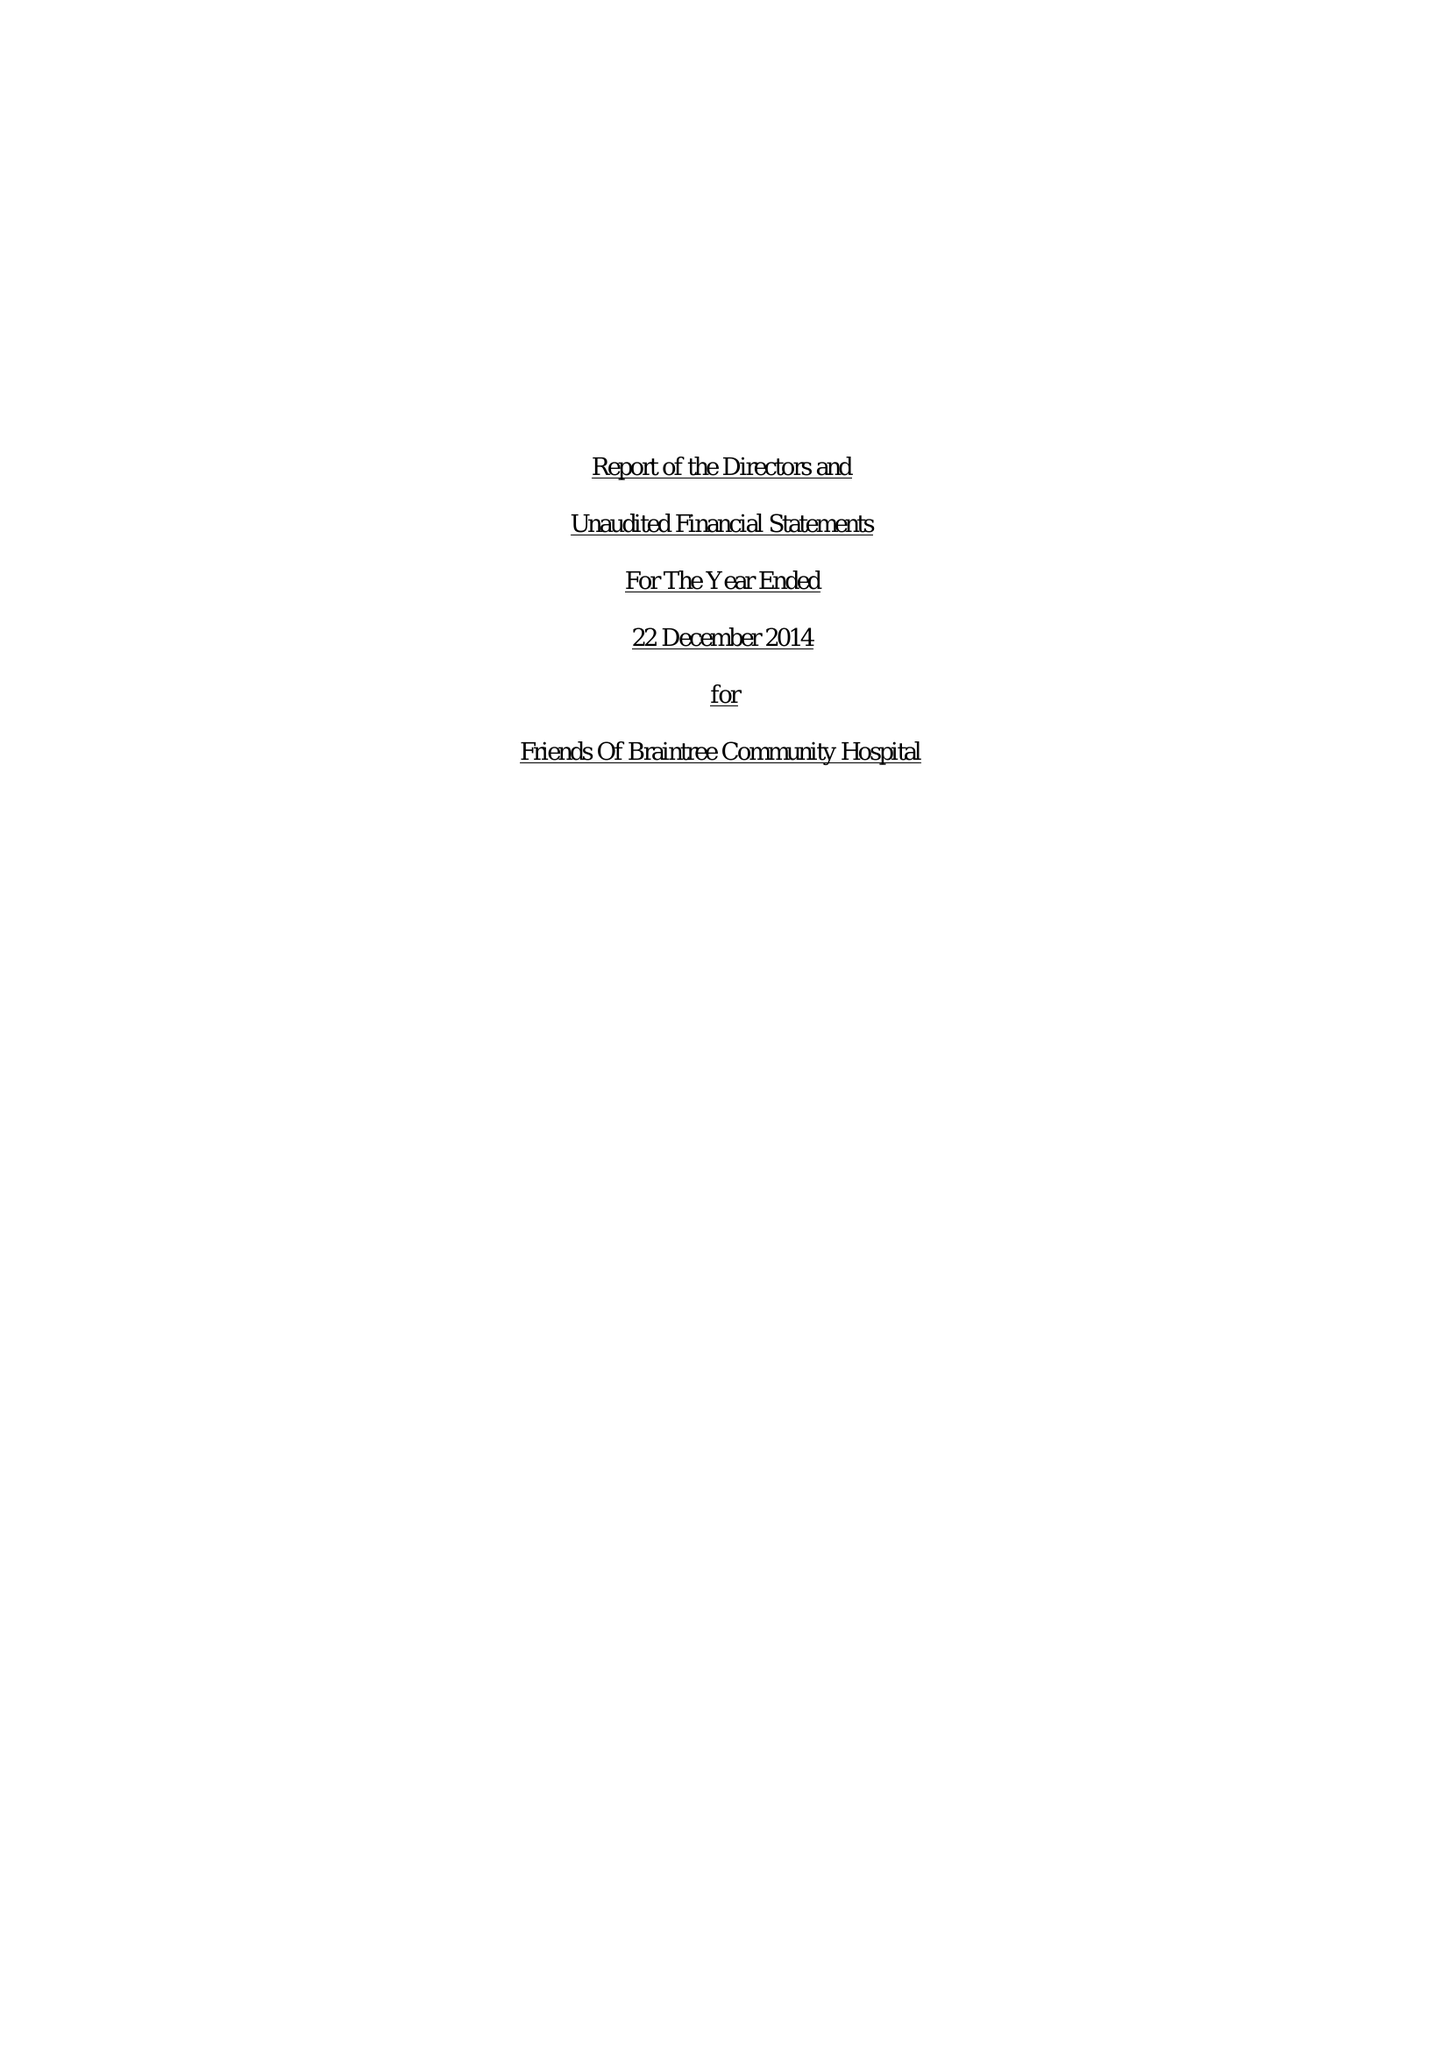What is the value for the report_date?
Answer the question using a single word or phrase. 2014-12-22 